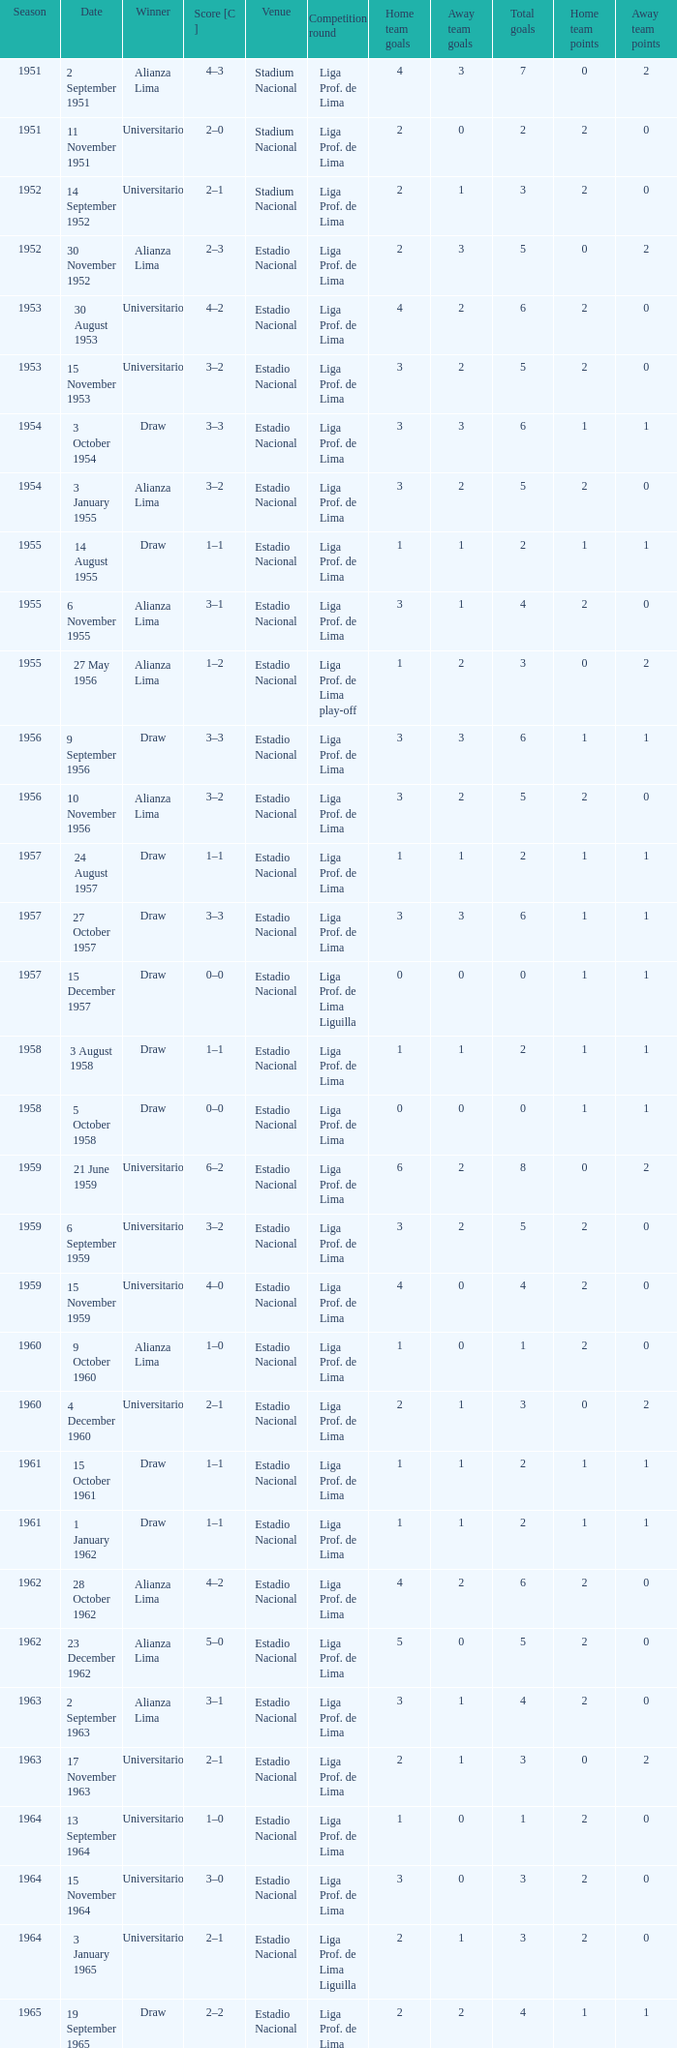What is the most recent season with a date of 27 October 1957? 1957.0. 